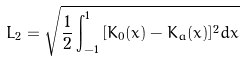<formula> <loc_0><loc_0><loc_500><loc_500>L _ { 2 } = \sqrt { \frac { 1 } { 2 } \int _ { - 1 } ^ { 1 } \, [ K _ { 0 } ( x ) - K _ { a } ( x ) ] ^ { 2 } d x }</formula> 